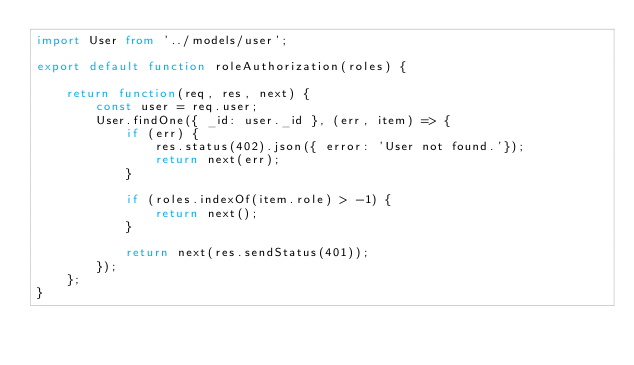<code> <loc_0><loc_0><loc_500><loc_500><_TypeScript_>import User from '../models/user';

export default function roleAuthorization(roles) {

    return function(req, res, next) {
        const user = req.user;
        User.findOne({ _id: user._id }, (err, item) => {
            if (err) {
                res.status(402).json({ error: 'User not found.'});
                return next(err);
            }

            if (roles.indexOf(item.role) > -1) {
                return next();
            }

            return next(res.sendStatus(401));
        });
    };
}
</code> 